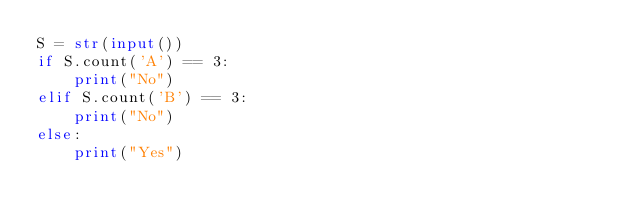<code> <loc_0><loc_0><loc_500><loc_500><_Python_>S = str(input())
if S.count('A') == 3:
    print("No")
elif S.count('B') == 3:
    print("No")
else:
    print("Yes")</code> 